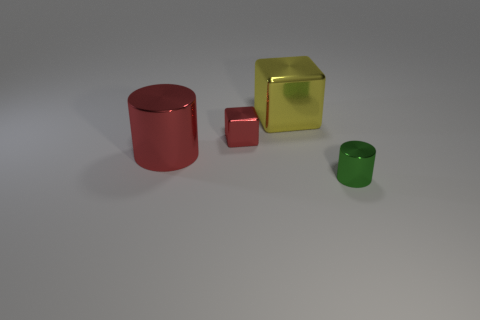Add 4 small cyan spheres. How many objects exist? 8 Subtract all small brown metallic spheres. Subtract all red things. How many objects are left? 2 Add 2 small green shiny cylinders. How many small green shiny cylinders are left? 3 Add 3 small metallic cylinders. How many small metallic cylinders exist? 4 Subtract 0 purple balls. How many objects are left? 4 